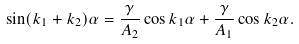<formula> <loc_0><loc_0><loc_500><loc_500>\sin ( k _ { 1 } + k _ { 2 } ) \alpha = \frac { \gamma } { A _ { 2 } } \cos k _ { 1 } \alpha + \frac { \gamma } { A _ { 1 } } \cos k _ { 2 } \alpha .</formula> 